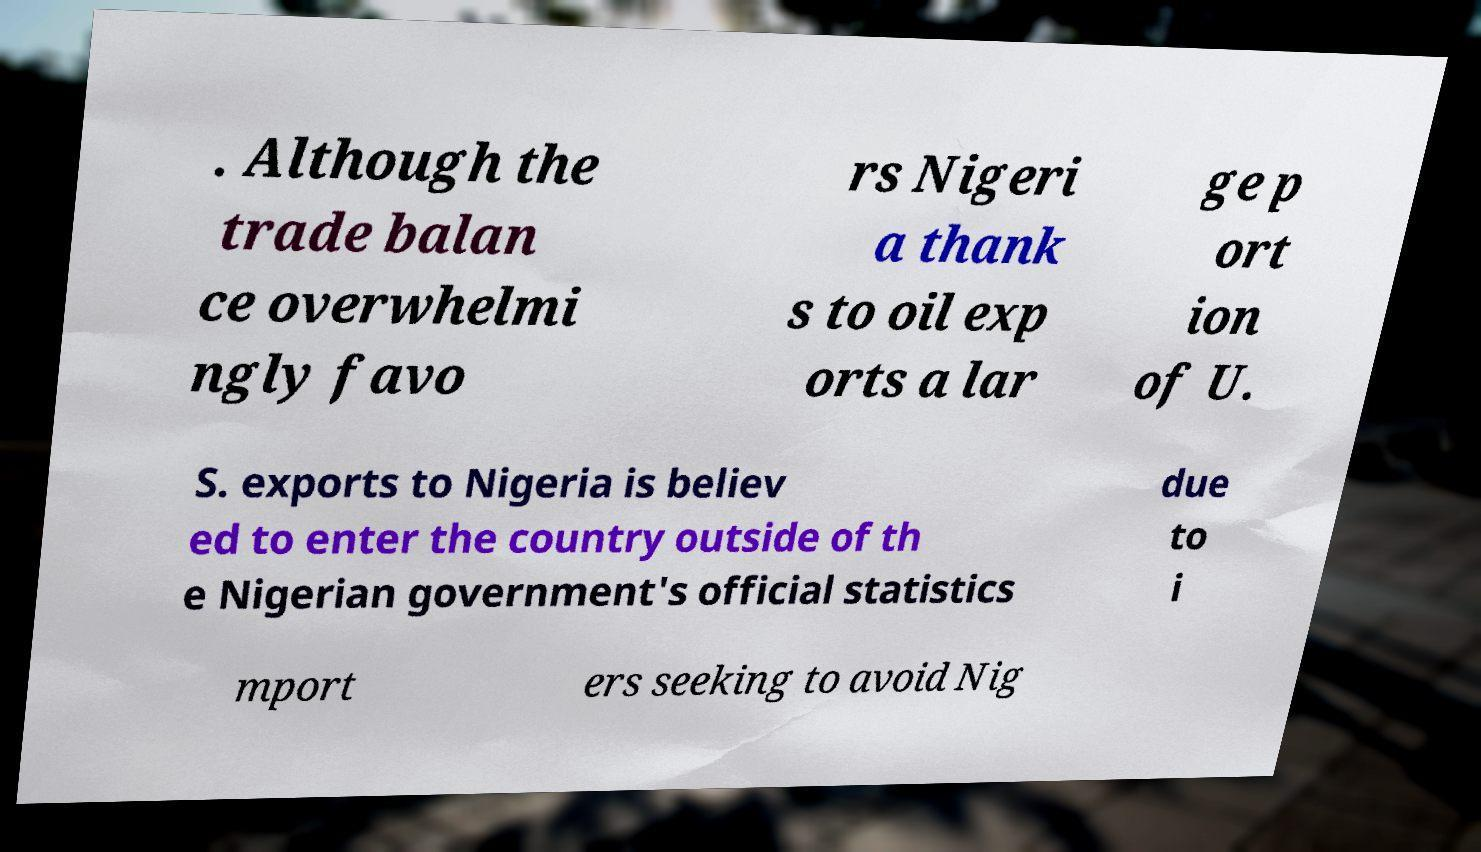I need the written content from this picture converted into text. Can you do that? . Although the trade balan ce overwhelmi ngly favo rs Nigeri a thank s to oil exp orts a lar ge p ort ion of U. S. exports to Nigeria is believ ed to enter the country outside of th e Nigerian government's official statistics due to i mport ers seeking to avoid Nig 